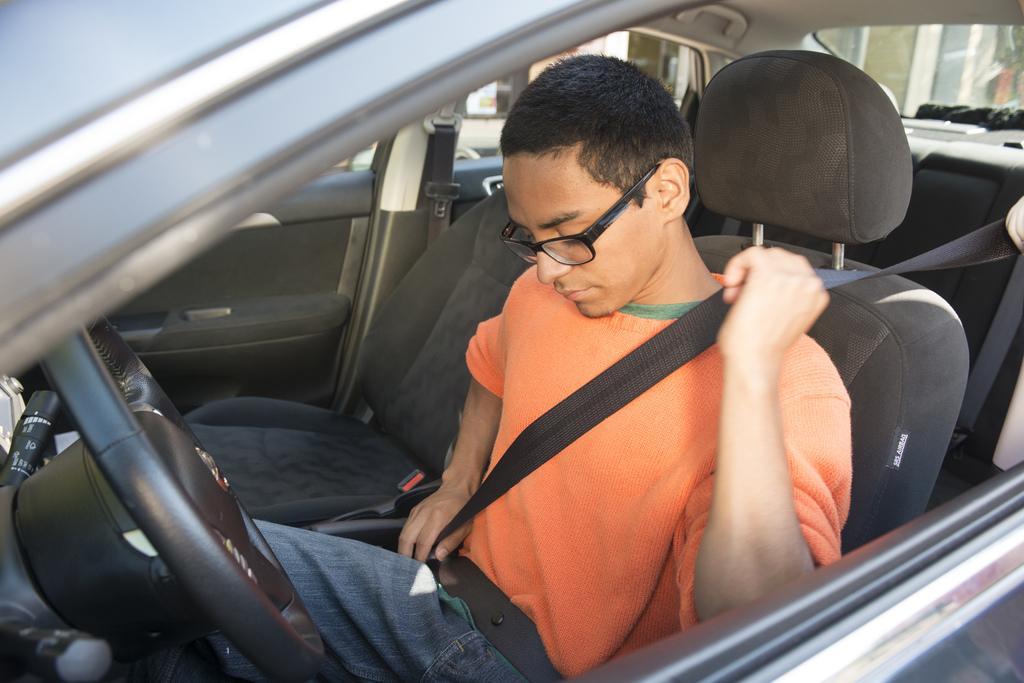How would you summarize this image in a sentence or two? A boy is sitting in the driver seat of a car, he wore an orange color t-shirt and black color spectacles. 